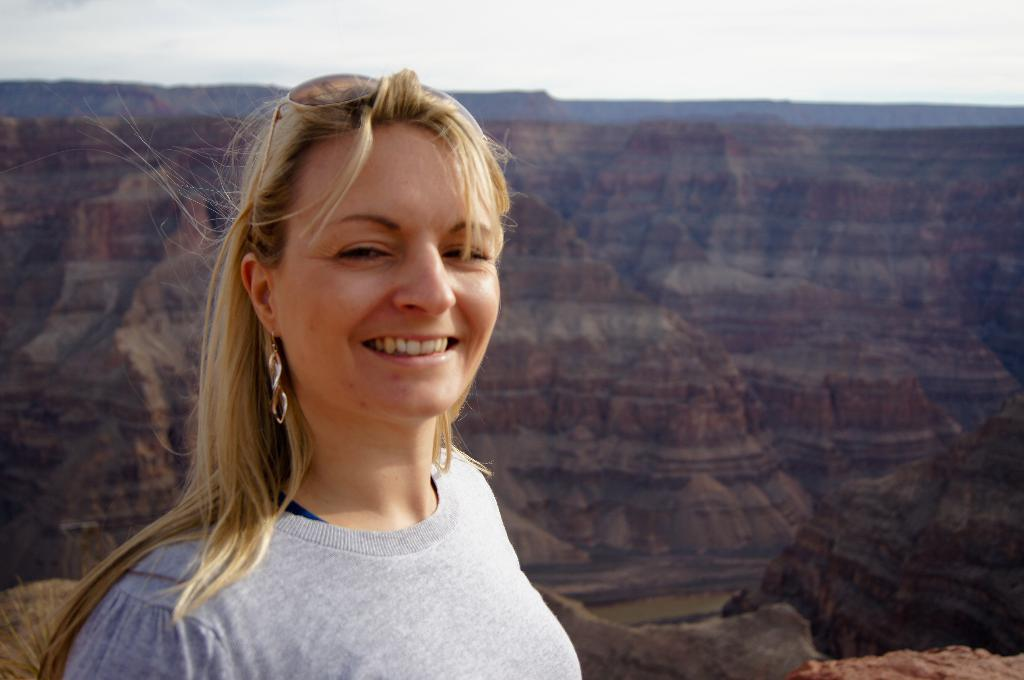What is the person in the image wearing? The person is wearing an ash-colored dress in the image. What is the facial expression of the person in the image? The person is smiling in the image. What can be seen in the background of the image? Mountains and the sky are visible in the background of the image. What type of cracker is being used as a prop in the image? There is no cracker present in the image. Can you hear the bell ringing in the image? There is no bell present in the image, so it cannot be heard. 